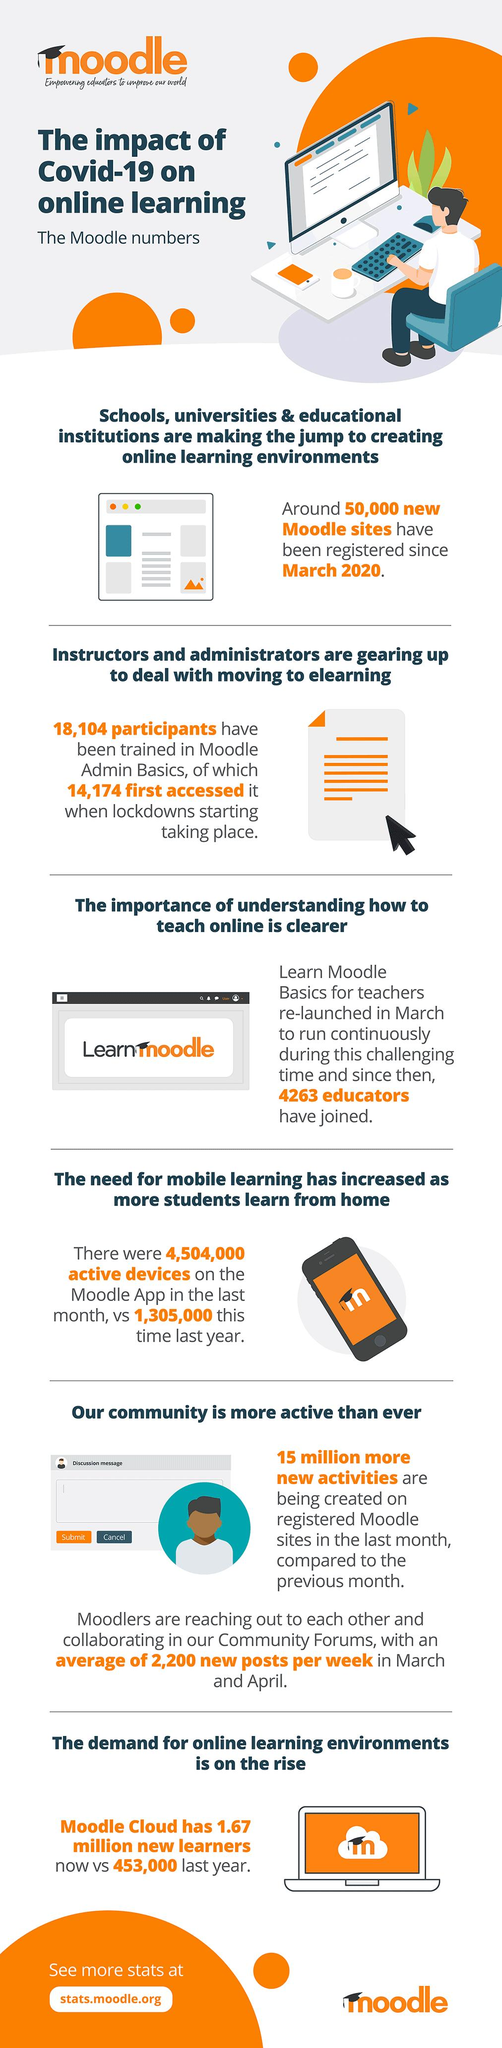List a handful of essential elements in this visual. Prior to the start of the pandemic lockdown, a total of 3,930 individuals had utilized Moodle Admin Basics. In the last month, there was an increase of 319,900 active users on the Moodle app. 